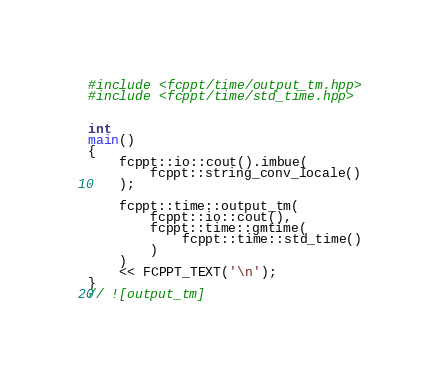<code> <loc_0><loc_0><loc_500><loc_500><_C++_>#include <fcppt/time/output_tm.hpp>
#include <fcppt/time/std_time.hpp>


int
main()
{
	fcppt::io::cout().imbue(
		fcppt::string_conv_locale()
	);

	fcppt::time::output_tm(
		fcppt::io::cout(),
		fcppt::time::gmtime(
			fcppt::time::std_time()
		)
	)
	<< FCPPT_TEXT('\n');
}
// ![output_tm]
</code> 